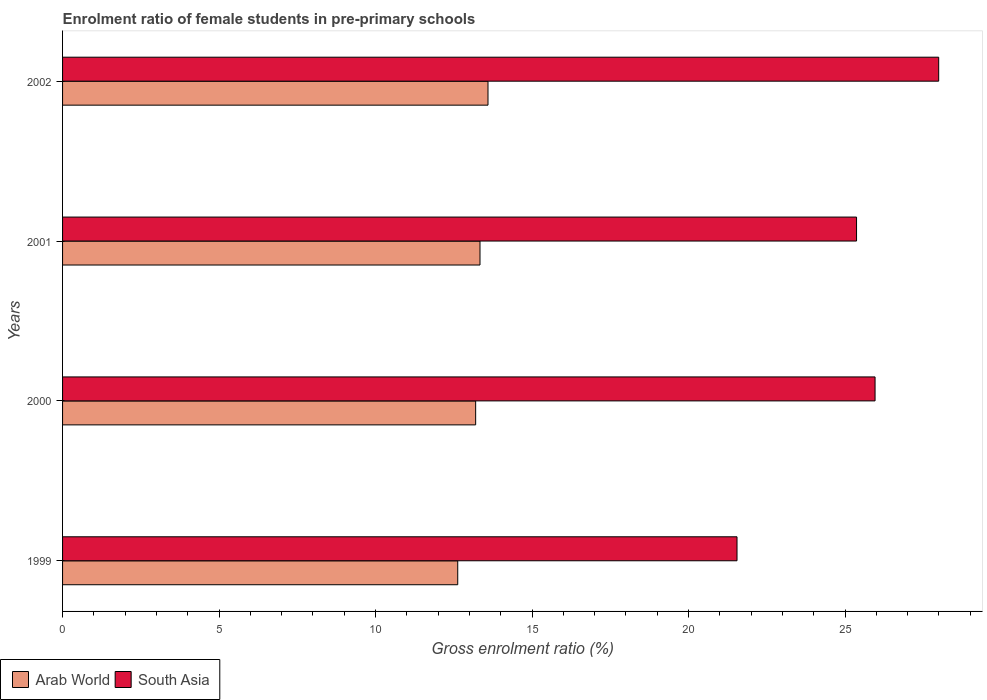Are the number of bars on each tick of the Y-axis equal?
Make the answer very short. Yes. What is the enrolment ratio of female students in pre-primary schools in South Asia in 2002?
Offer a very short reply. 27.99. Across all years, what is the maximum enrolment ratio of female students in pre-primary schools in Arab World?
Your answer should be compact. 13.59. Across all years, what is the minimum enrolment ratio of female students in pre-primary schools in Arab World?
Keep it short and to the point. 12.62. In which year was the enrolment ratio of female students in pre-primary schools in Arab World maximum?
Give a very brief answer. 2002. What is the total enrolment ratio of female students in pre-primary schools in South Asia in the graph?
Your answer should be very brief. 100.86. What is the difference between the enrolment ratio of female students in pre-primary schools in South Asia in 1999 and that in 2000?
Make the answer very short. -4.41. What is the difference between the enrolment ratio of female students in pre-primary schools in South Asia in 2001 and the enrolment ratio of female students in pre-primary schools in Arab World in 1999?
Offer a very short reply. 12.74. What is the average enrolment ratio of female students in pre-primary schools in South Asia per year?
Offer a terse response. 25.22. In the year 1999, what is the difference between the enrolment ratio of female students in pre-primary schools in Arab World and enrolment ratio of female students in pre-primary schools in South Asia?
Provide a succinct answer. -8.92. What is the ratio of the enrolment ratio of female students in pre-primary schools in Arab World in 2000 to that in 2001?
Keep it short and to the point. 0.99. Is the enrolment ratio of female students in pre-primary schools in Arab World in 2000 less than that in 2001?
Your answer should be very brief. Yes. What is the difference between the highest and the second highest enrolment ratio of female students in pre-primary schools in South Asia?
Ensure brevity in your answer.  2.03. What is the difference between the highest and the lowest enrolment ratio of female students in pre-primary schools in South Asia?
Make the answer very short. 6.44. In how many years, is the enrolment ratio of female students in pre-primary schools in Arab World greater than the average enrolment ratio of female students in pre-primary schools in Arab World taken over all years?
Provide a short and direct response. 3. What does the 2nd bar from the top in 2000 represents?
Offer a terse response. Arab World. Are the values on the major ticks of X-axis written in scientific E-notation?
Your answer should be very brief. No. Does the graph contain any zero values?
Your answer should be very brief. No. How many legend labels are there?
Make the answer very short. 2. How are the legend labels stacked?
Your response must be concise. Horizontal. What is the title of the graph?
Keep it short and to the point. Enrolment ratio of female students in pre-primary schools. Does "Middle East & North Africa (developing only)" appear as one of the legend labels in the graph?
Make the answer very short. No. What is the label or title of the Y-axis?
Give a very brief answer. Years. What is the Gross enrolment ratio (%) of Arab World in 1999?
Keep it short and to the point. 12.62. What is the Gross enrolment ratio (%) in South Asia in 1999?
Provide a succinct answer. 21.55. What is the Gross enrolment ratio (%) in Arab World in 2000?
Give a very brief answer. 13.2. What is the Gross enrolment ratio (%) of South Asia in 2000?
Your answer should be very brief. 25.96. What is the Gross enrolment ratio (%) in Arab World in 2001?
Provide a succinct answer. 13.34. What is the Gross enrolment ratio (%) in South Asia in 2001?
Give a very brief answer. 25.37. What is the Gross enrolment ratio (%) in Arab World in 2002?
Give a very brief answer. 13.59. What is the Gross enrolment ratio (%) in South Asia in 2002?
Provide a succinct answer. 27.99. Across all years, what is the maximum Gross enrolment ratio (%) in Arab World?
Ensure brevity in your answer.  13.59. Across all years, what is the maximum Gross enrolment ratio (%) of South Asia?
Your answer should be compact. 27.99. Across all years, what is the minimum Gross enrolment ratio (%) of Arab World?
Offer a very short reply. 12.62. Across all years, what is the minimum Gross enrolment ratio (%) of South Asia?
Your response must be concise. 21.55. What is the total Gross enrolment ratio (%) of Arab World in the graph?
Keep it short and to the point. 52.75. What is the total Gross enrolment ratio (%) of South Asia in the graph?
Make the answer very short. 100.86. What is the difference between the Gross enrolment ratio (%) of Arab World in 1999 and that in 2000?
Your answer should be very brief. -0.57. What is the difference between the Gross enrolment ratio (%) in South Asia in 1999 and that in 2000?
Your answer should be compact. -4.41. What is the difference between the Gross enrolment ratio (%) in Arab World in 1999 and that in 2001?
Your answer should be compact. -0.71. What is the difference between the Gross enrolment ratio (%) in South Asia in 1999 and that in 2001?
Your response must be concise. -3.82. What is the difference between the Gross enrolment ratio (%) of Arab World in 1999 and that in 2002?
Provide a short and direct response. -0.97. What is the difference between the Gross enrolment ratio (%) of South Asia in 1999 and that in 2002?
Your answer should be compact. -6.44. What is the difference between the Gross enrolment ratio (%) of Arab World in 2000 and that in 2001?
Provide a succinct answer. -0.14. What is the difference between the Gross enrolment ratio (%) in South Asia in 2000 and that in 2001?
Offer a terse response. 0.59. What is the difference between the Gross enrolment ratio (%) in Arab World in 2000 and that in 2002?
Your response must be concise. -0.39. What is the difference between the Gross enrolment ratio (%) in South Asia in 2000 and that in 2002?
Your response must be concise. -2.03. What is the difference between the Gross enrolment ratio (%) in Arab World in 2001 and that in 2002?
Offer a very short reply. -0.26. What is the difference between the Gross enrolment ratio (%) in South Asia in 2001 and that in 2002?
Offer a very short reply. -2.62. What is the difference between the Gross enrolment ratio (%) in Arab World in 1999 and the Gross enrolment ratio (%) in South Asia in 2000?
Make the answer very short. -13.33. What is the difference between the Gross enrolment ratio (%) of Arab World in 1999 and the Gross enrolment ratio (%) of South Asia in 2001?
Provide a short and direct response. -12.74. What is the difference between the Gross enrolment ratio (%) in Arab World in 1999 and the Gross enrolment ratio (%) in South Asia in 2002?
Provide a succinct answer. -15.37. What is the difference between the Gross enrolment ratio (%) in Arab World in 2000 and the Gross enrolment ratio (%) in South Asia in 2001?
Provide a short and direct response. -12.17. What is the difference between the Gross enrolment ratio (%) in Arab World in 2000 and the Gross enrolment ratio (%) in South Asia in 2002?
Your response must be concise. -14.79. What is the difference between the Gross enrolment ratio (%) of Arab World in 2001 and the Gross enrolment ratio (%) of South Asia in 2002?
Your answer should be very brief. -14.65. What is the average Gross enrolment ratio (%) of Arab World per year?
Make the answer very short. 13.19. What is the average Gross enrolment ratio (%) in South Asia per year?
Offer a terse response. 25.22. In the year 1999, what is the difference between the Gross enrolment ratio (%) in Arab World and Gross enrolment ratio (%) in South Asia?
Keep it short and to the point. -8.92. In the year 2000, what is the difference between the Gross enrolment ratio (%) of Arab World and Gross enrolment ratio (%) of South Asia?
Offer a terse response. -12.76. In the year 2001, what is the difference between the Gross enrolment ratio (%) in Arab World and Gross enrolment ratio (%) in South Asia?
Your response must be concise. -12.03. In the year 2002, what is the difference between the Gross enrolment ratio (%) of Arab World and Gross enrolment ratio (%) of South Asia?
Provide a short and direct response. -14.4. What is the ratio of the Gross enrolment ratio (%) in Arab World in 1999 to that in 2000?
Make the answer very short. 0.96. What is the ratio of the Gross enrolment ratio (%) in South Asia in 1999 to that in 2000?
Your answer should be very brief. 0.83. What is the ratio of the Gross enrolment ratio (%) in Arab World in 1999 to that in 2001?
Offer a terse response. 0.95. What is the ratio of the Gross enrolment ratio (%) in South Asia in 1999 to that in 2001?
Provide a short and direct response. 0.85. What is the ratio of the Gross enrolment ratio (%) in Arab World in 1999 to that in 2002?
Ensure brevity in your answer.  0.93. What is the ratio of the Gross enrolment ratio (%) of South Asia in 1999 to that in 2002?
Offer a very short reply. 0.77. What is the ratio of the Gross enrolment ratio (%) of Arab World in 2000 to that in 2001?
Your response must be concise. 0.99. What is the ratio of the Gross enrolment ratio (%) of South Asia in 2000 to that in 2001?
Keep it short and to the point. 1.02. What is the ratio of the Gross enrolment ratio (%) of Arab World in 2000 to that in 2002?
Provide a succinct answer. 0.97. What is the ratio of the Gross enrolment ratio (%) of South Asia in 2000 to that in 2002?
Your answer should be very brief. 0.93. What is the ratio of the Gross enrolment ratio (%) of Arab World in 2001 to that in 2002?
Provide a short and direct response. 0.98. What is the ratio of the Gross enrolment ratio (%) in South Asia in 2001 to that in 2002?
Provide a succinct answer. 0.91. What is the difference between the highest and the second highest Gross enrolment ratio (%) of Arab World?
Provide a succinct answer. 0.26. What is the difference between the highest and the second highest Gross enrolment ratio (%) of South Asia?
Provide a short and direct response. 2.03. What is the difference between the highest and the lowest Gross enrolment ratio (%) of South Asia?
Offer a very short reply. 6.44. 